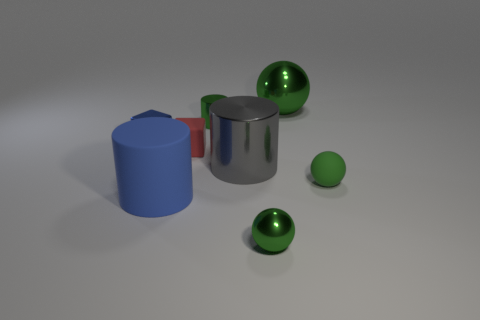Subtract all small shiny cylinders. How many cylinders are left? 2 Add 1 matte spheres. How many objects exist? 9 Add 7 tiny metallic blocks. How many tiny metallic blocks are left? 8 Add 6 large red rubber cylinders. How many large red rubber cylinders exist? 6 Subtract all green cylinders. How many cylinders are left? 2 Subtract 0 gray balls. How many objects are left? 8 Subtract all cubes. How many objects are left? 6 Subtract 2 spheres. How many spheres are left? 1 Subtract all red cylinders. Subtract all yellow balls. How many cylinders are left? 3 Subtract all green balls. Subtract all gray things. How many objects are left? 4 